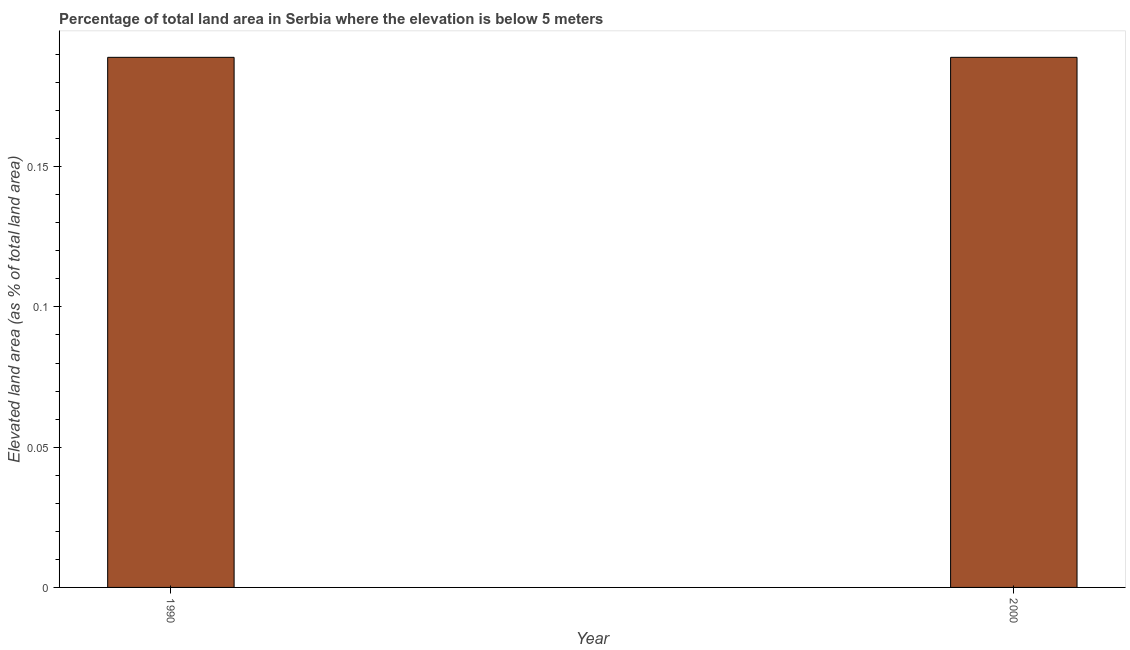Does the graph contain any zero values?
Offer a terse response. No. What is the title of the graph?
Make the answer very short. Percentage of total land area in Serbia where the elevation is below 5 meters. What is the label or title of the X-axis?
Provide a succinct answer. Year. What is the label or title of the Y-axis?
Your answer should be compact. Elevated land area (as % of total land area). What is the total elevated land area in 1990?
Your answer should be very brief. 0.19. Across all years, what is the maximum total elevated land area?
Ensure brevity in your answer.  0.19. Across all years, what is the minimum total elevated land area?
Keep it short and to the point. 0.19. In which year was the total elevated land area maximum?
Make the answer very short. 1990. In which year was the total elevated land area minimum?
Offer a very short reply. 1990. What is the sum of the total elevated land area?
Keep it short and to the point. 0.38. What is the average total elevated land area per year?
Your response must be concise. 0.19. What is the median total elevated land area?
Keep it short and to the point. 0.19. In how many years, is the total elevated land area greater than 0.04 %?
Ensure brevity in your answer.  2. What is the ratio of the total elevated land area in 1990 to that in 2000?
Make the answer very short. 1. Is the total elevated land area in 1990 less than that in 2000?
Provide a succinct answer. No. Are all the bars in the graph horizontal?
Your answer should be very brief. No. What is the Elevated land area (as % of total land area) in 1990?
Ensure brevity in your answer.  0.19. What is the Elevated land area (as % of total land area) in 2000?
Make the answer very short. 0.19. What is the difference between the Elevated land area (as % of total land area) in 1990 and 2000?
Your response must be concise. 0. What is the ratio of the Elevated land area (as % of total land area) in 1990 to that in 2000?
Ensure brevity in your answer.  1. 